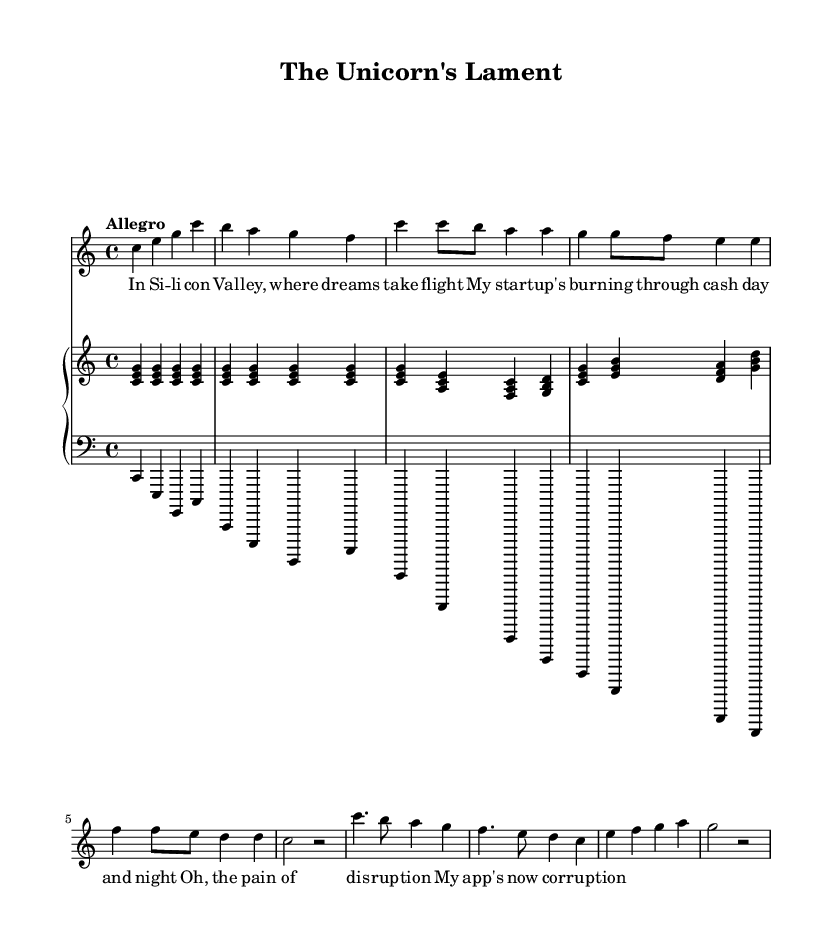What is the key signature of this music? The key signature indicated at the beginning of the score is C major, which has no sharps or flats listed.
Answer: C major What is the time signature of this music? The time signature shown in the score is 4/4, which means there are four beats per measure.
Answer: 4/4 What is the tempo marking for this piece? The tempo marking at the beginning states "Allegro," which indicates a fast and lively pace for the music.
Answer: Allegro How many measures are in the soprano part? By counting the number of measures in the soprano line, there are a total of 8 measures present in the part shown.
Answer: 8 What is the highest note in the soprano line? The soprano line contains a high C, which is noted at the beginning of the vocal line, indicating it is the highest pitch used.
Answer: C How many notes are present in the piano part of the first measure? The first measure of the piano part contains three notes (C, E, and G), as indicated by the chord structure written in the score.
Answer: 3 Which character in the opera is likely the one lamenting about Silicon Valley? The lyrics suggest that the character reflects on struggles related to their startup experience, hinting that the character is a startup founder.
Answer: Founder 